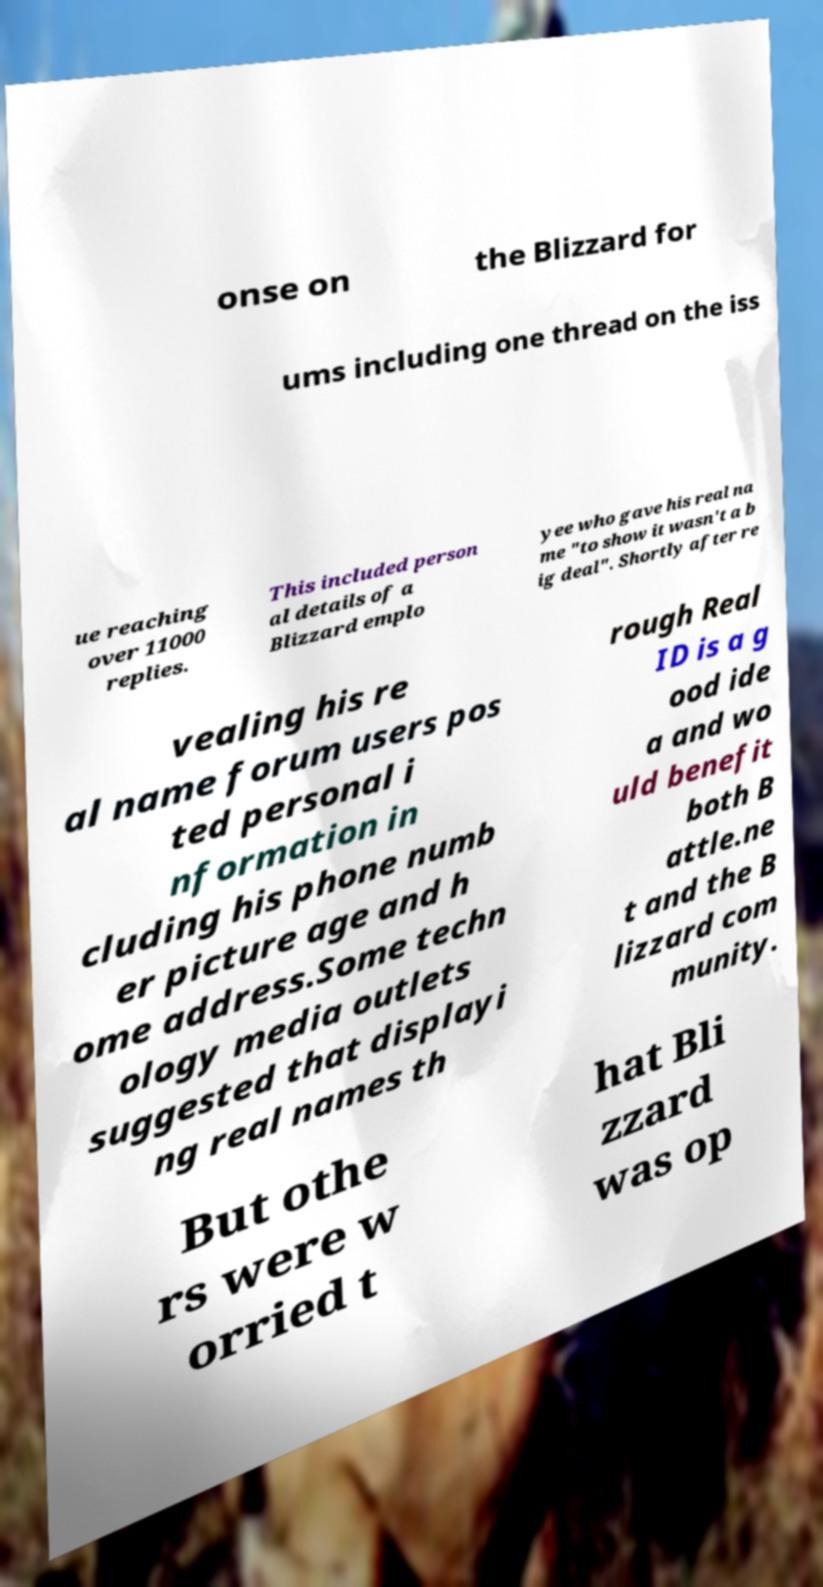There's text embedded in this image that I need extracted. Can you transcribe it verbatim? onse on the Blizzard for ums including one thread on the iss ue reaching over 11000 replies. This included person al details of a Blizzard emplo yee who gave his real na me "to show it wasn't a b ig deal". Shortly after re vealing his re al name forum users pos ted personal i nformation in cluding his phone numb er picture age and h ome address.Some techn ology media outlets suggested that displayi ng real names th rough Real ID is a g ood ide a and wo uld benefit both B attle.ne t and the B lizzard com munity. But othe rs were w orried t hat Bli zzard was op 